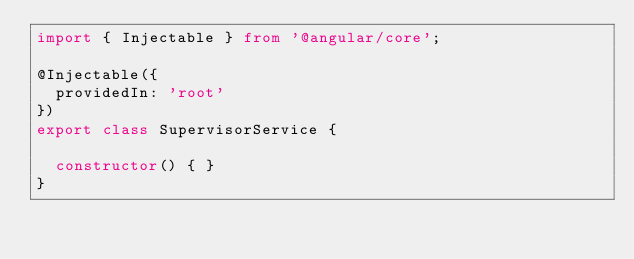Convert code to text. <code><loc_0><loc_0><loc_500><loc_500><_TypeScript_>import { Injectable } from '@angular/core';

@Injectable({
  providedIn: 'root'
})
export class SupervisorService {

  constructor() { }
}
</code> 